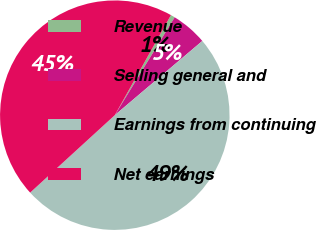Convert chart to OTSL. <chart><loc_0><loc_0><loc_500><loc_500><pie_chart><fcel>Revenue<fcel>Selling general and<fcel>Earnings from continuing<fcel>Net earnings<nl><fcel>0.6%<fcel>5.07%<fcel>49.4%<fcel>44.93%<nl></chart> 